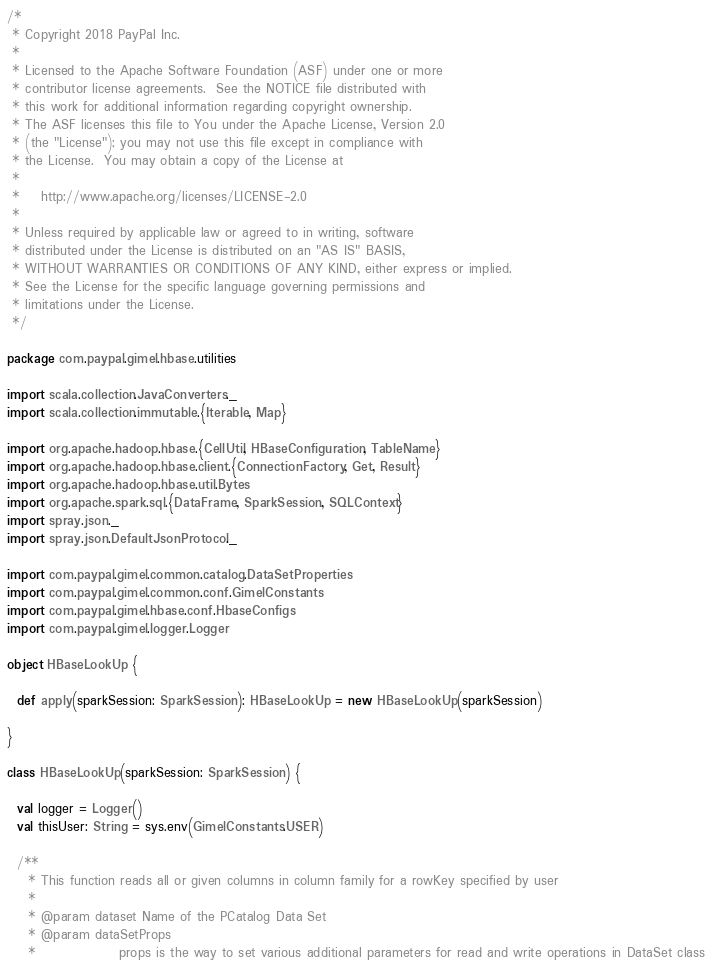<code> <loc_0><loc_0><loc_500><loc_500><_Scala_>/*
 * Copyright 2018 PayPal Inc.
 *
 * Licensed to the Apache Software Foundation (ASF) under one or more
 * contributor license agreements.  See the NOTICE file distributed with
 * this work for additional information regarding copyright ownership.
 * The ASF licenses this file to You under the Apache License, Version 2.0
 * (the "License"); you may not use this file except in compliance with
 * the License.  You may obtain a copy of the License at
 *
 *    http://www.apache.org/licenses/LICENSE-2.0
 *
 * Unless required by applicable law or agreed to in writing, software
 * distributed under the License is distributed on an "AS IS" BASIS,
 * WITHOUT WARRANTIES OR CONDITIONS OF ANY KIND, either express or implied.
 * See the License for the specific language governing permissions and
 * limitations under the License.
 */

package com.paypal.gimel.hbase.utilities

import scala.collection.JavaConverters._
import scala.collection.immutable.{Iterable, Map}

import org.apache.hadoop.hbase.{CellUtil, HBaseConfiguration, TableName}
import org.apache.hadoop.hbase.client.{ConnectionFactory, Get, Result}
import org.apache.hadoop.hbase.util.Bytes
import org.apache.spark.sql.{DataFrame, SparkSession, SQLContext}
import spray.json._
import spray.json.DefaultJsonProtocol._

import com.paypal.gimel.common.catalog.DataSetProperties
import com.paypal.gimel.common.conf.GimelConstants
import com.paypal.gimel.hbase.conf.HbaseConfigs
import com.paypal.gimel.logger.Logger

object HBaseLookUp {

  def apply(sparkSession: SparkSession): HBaseLookUp = new HBaseLookUp(sparkSession)

}

class HBaseLookUp(sparkSession: SparkSession) {

  val logger = Logger()
  val thisUser: String = sys.env(GimelConstants.USER)

  /**
    * This function reads all or given columns in column family for a rowKey specified by user
    *
    * @param dataset Name of the PCatalog Data Set
    * @param dataSetProps
    *                props is the way to set various additional parameters for read and write operations in DataSet class</code> 